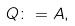Convert formula to latex. <formula><loc_0><loc_0><loc_500><loc_500>Q \colon = A ,</formula> 